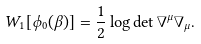<formula> <loc_0><loc_0><loc_500><loc_500>W _ { 1 } [ \phi _ { 0 } ( \beta ) ] = \frac { 1 } { 2 } \log \det \nabla ^ { \mu } \nabla _ { \mu } .</formula> 